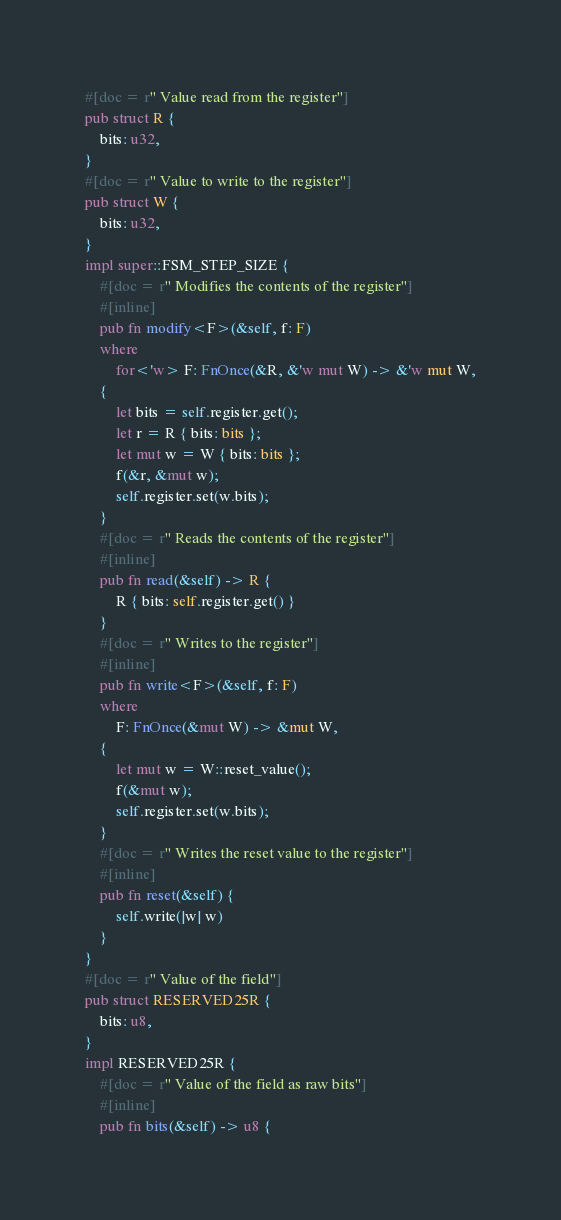<code> <loc_0><loc_0><loc_500><loc_500><_Rust_>#[doc = r" Value read from the register"]
pub struct R {
    bits: u32,
}
#[doc = r" Value to write to the register"]
pub struct W {
    bits: u32,
}
impl super::FSM_STEP_SIZE {
    #[doc = r" Modifies the contents of the register"]
    #[inline]
    pub fn modify<F>(&self, f: F)
    where
        for<'w> F: FnOnce(&R, &'w mut W) -> &'w mut W,
    {
        let bits = self.register.get();
        let r = R { bits: bits };
        let mut w = W { bits: bits };
        f(&r, &mut w);
        self.register.set(w.bits);
    }
    #[doc = r" Reads the contents of the register"]
    #[inline]
    pub fn read(&self) -> R {
        R { bits: self.register.get() }
    }
    #[doc = r" Writes to the register"]
    #[inline]
    pub fn write<F>(&self, f: F)
    where
        F: FnOnce(&mut W) -> &mut W,
    {
        let mut w = W::reset_value();
        f(&mut w);
        self.register.set(w.bits);
    }
    #[doc = r" Writes the reset value to the register"]
    #[inline]
    pub fn reset(&self) {
        self.write(|w| w)
    }
}
#[doc = r" Value of the field"]
pub struct RESERVED25R {
    bits: u8,
}
impl RESERVED25R {
    #[doc = r" Value of the field as raw bits"]
    #[inline]
    pub fn bits(&self) -> u8 {</code> 